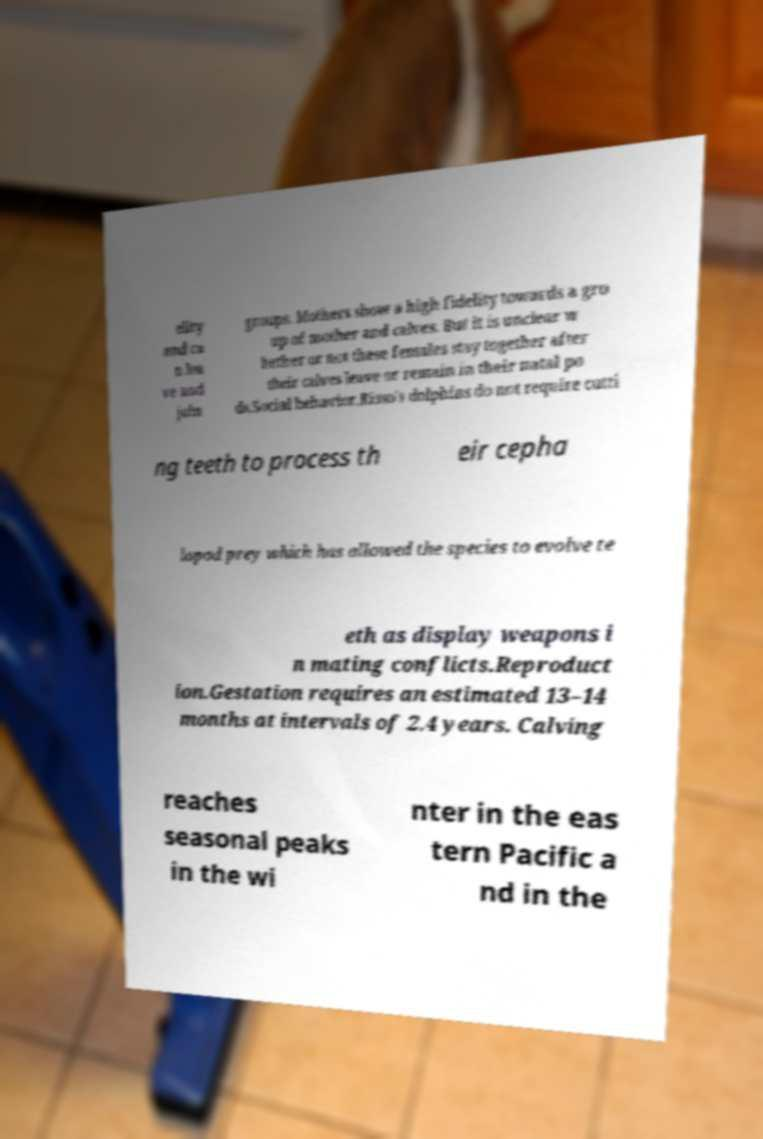Please identify and transcribe the text found in this image. elity and ca n lea ve and join groups. Mothers show a high fidelity towards a gro up of mother and calves. But it is unclear w hether or not these females stay together after their calves leave or remain in their natal po ds.Social behavior.Risso's dolphins do not require cutti ng teeth to process th eir cepha lopod prey which has allowed the species to evolve te eth as display weapons i n mating conflicts.Reproduct ion.Gestation requires an estimated 13–14 months at intervals of 2.4 years. Calving reaches seasonal peaks in the wi nter in the eas tern Pacific a nd in the 